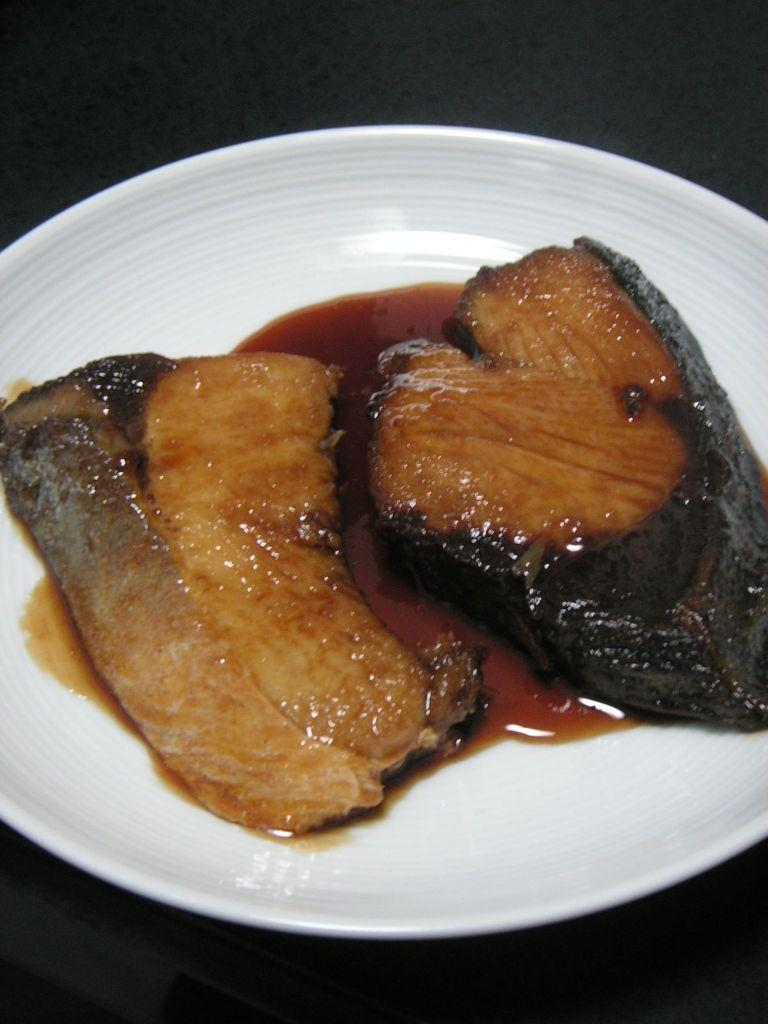What is on the plate that is visible in the image? There are food items on a plate in the image. What color is the plate? The plate is white. What can be seen in the background of the image? The background of the image is dark. How many feet are visible in the image? There are no feet visible in the image. What type of ray is swimming in the background of the image? There is no ray present in the image; the background is dark. 